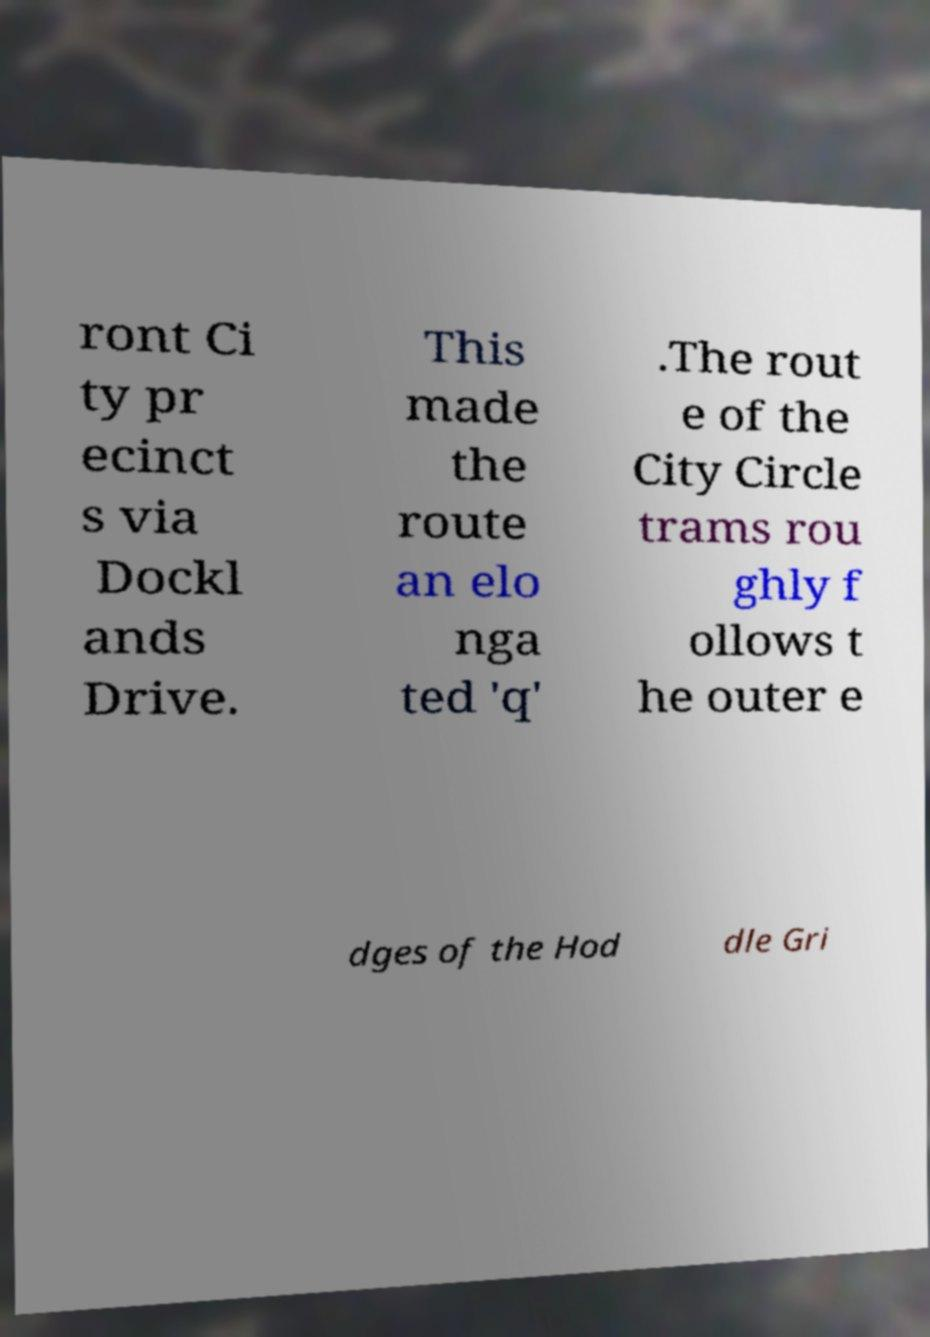Can you accurately transcribe the text from the provided image for me? ront Ci ty pr ecinct s via Dockl ands Drive. This made the route an elo nga ted 'q' .The rout e of the City Circle trams rou ghly f ollows t he outer e dges of the Hod dle Gri 